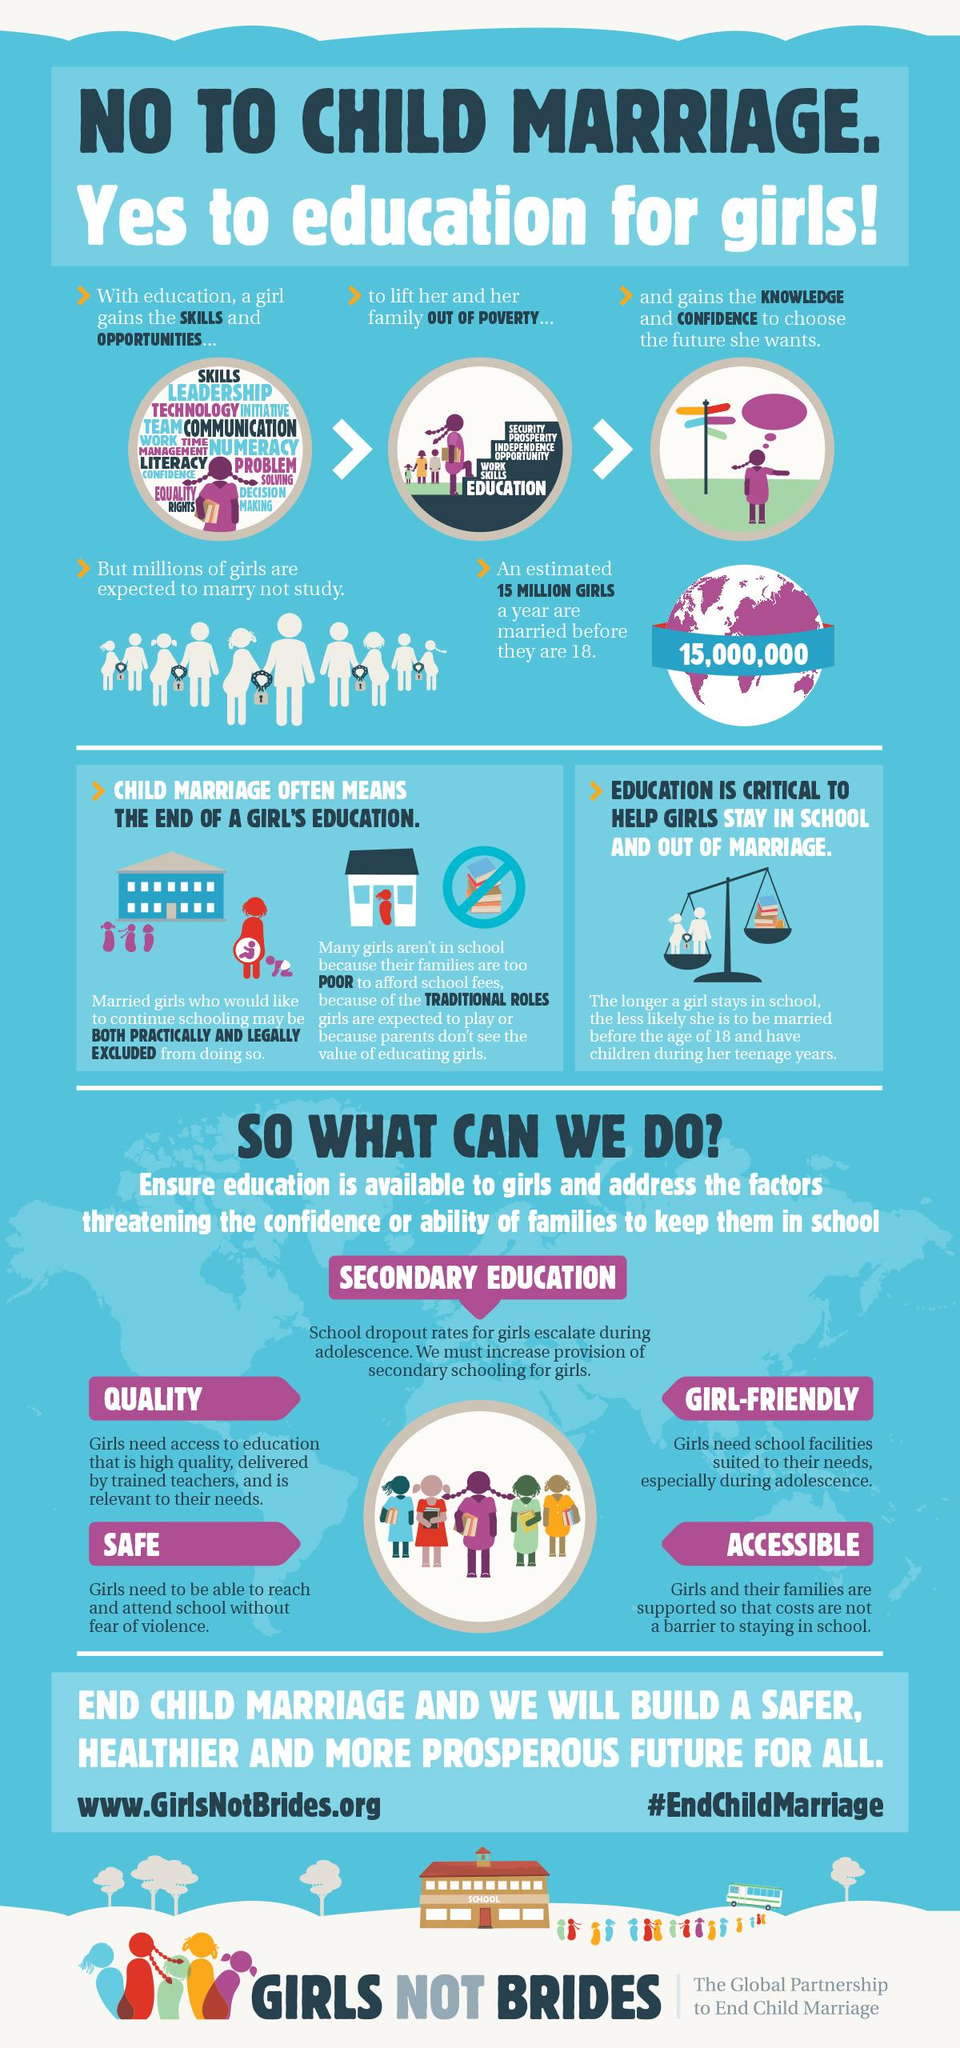Point out several critical features in this image. The solution for building a safer, healthier, and more prosperous future for all is to end child marriage. It is estimated that approximately 15,000,000 minor girls around the world are married each year. 